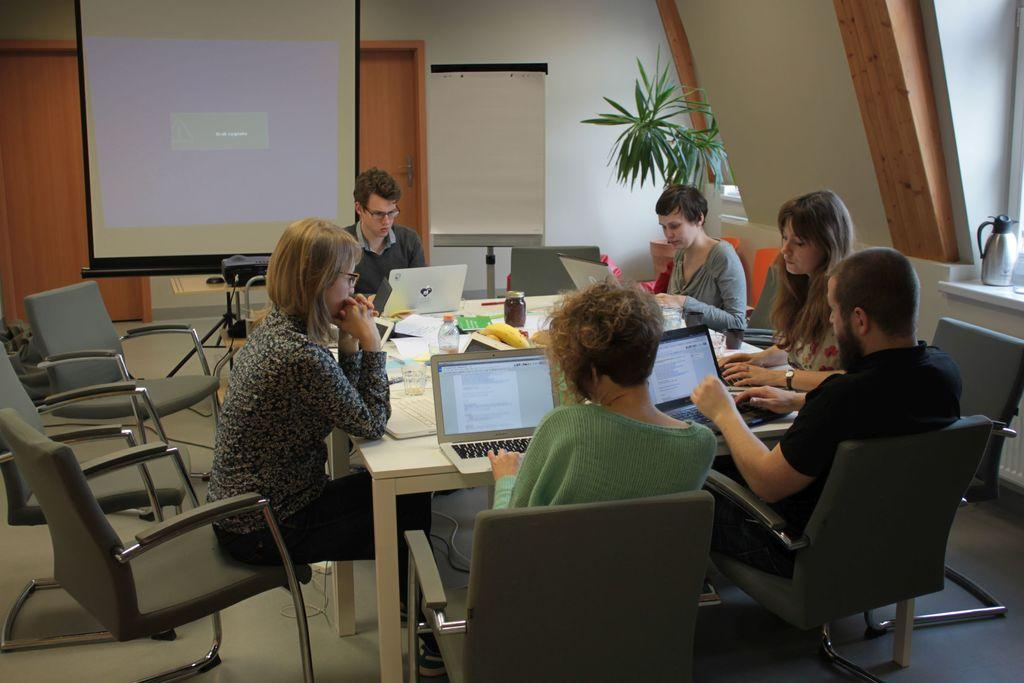How many people are in the image? There are six persons in the image. What are the persons doing in the image? The persons are sitting on a chair and working on a laptop. What can be seen in the background of the image? There is a screen and a door in the background of the image. What type of book is the person reading in the cave in the image? There is no cave or book present in the image; it features six persons sitting on chairs and working on laptops. 